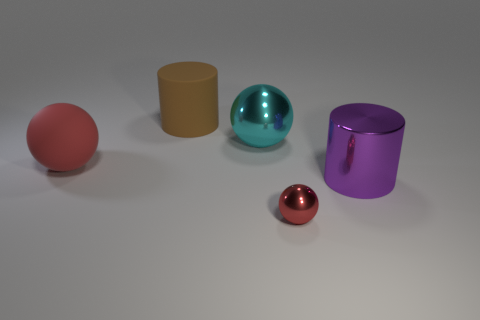Subtract all red metallic spheres. How many spheres are left? 2 Add 1 tiny gray metallic spheres. How many objects exist? 6 Subtract all cylinders. How many objects are left? 3 Subtract all purple cylinders. How many cylinders are left? 1 Subtract 1 red balls. How many objects are left? 4 Subtract 1 cylinders. How many cylinders are left? 1 Subtract all gray cylinders. Subtract all red blocks. How many cylinders are left? 2 Subtract all green cubes. How many brown cylinders are left? 1 Subtract all large red matte things. Subtract all big red rubber objects. How many objects are left? 3 Add 2 big matte balls. How many big matte balls are left? 3 